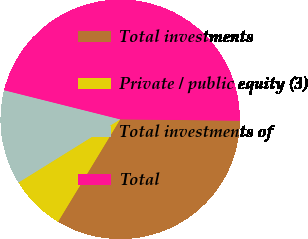Convert chart to OTSL. <chart><loc_0><loc_0><loc_500><loc_500><pie_chart><fcel>Total investments<fcel>Private / public equity (3)<fcel>Total investments of<fcel>Total<nl><fcel>33.5%<fcel>7.47%<fcel>12.76%<fcel>46.26%<nl></chart> 